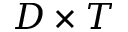<formula> <loc_0><loc_0><loc_500><loc_500>D \times T</formula> 